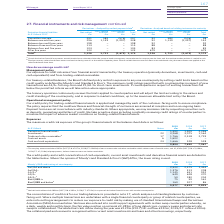According to Bt Group Plc's financial document, What is the cash collateral held by the company in 2019? According to the financial document, £638m. The relevant text states: "a We hold cash collateral of £638m (2017/18: £492m, 2016/17: £702m) in respect of derivative financial assets with certain counterparti..." Also, What is the fair value position in 2019? According to the financial document, £3,289m. The relevant text states: "monthly basis, the fair value position on notional £3,289m of long dated cross-currency swaps and interest rate swaps is collateralised. The related net cash i..." Also, What are the years that Moody’s / S&P credit rating of counterparty is provided? The document contains multiple relevant values: 2017, 2018, 2019. From the document: "At 31 March Notes 2019 £m 2018 £m 2017 £m At 31 March Notes 2019 £m 2018 £m 2017 £m At 31 March Notes 2019 £m 2018 £m 2017 £m..." Also, can you calculate: What is the change in the Aa2/AA and above from 2018 to 2019? Based on the calculation: 2,522 - 2,575, the result is -53 (in millions). This is based on the information: "Aa2/AA and above 2,522 2,575 1,444 Aa3/AA– 1,376 313 208 A1/A+ a 1,145 651 952 A2/A a 649 628 370 A3/A– a 50 180 204 Baa1/ Aa2/AA and above 2,522 2,575 1,444 Aa3/AA– 1,376 313 208 A1/A+ a 1,145 651 95..." The key data points involved are: 2,522, 2,575. Also, can you calculate: What is the average Aa3/AA– for 2017-2019? To answer this question, I need to perform calculations using the financial data. The calculation is: (1,376 + 313 + 208) / 3, which equals 632.33 (in millions). This is based on the information: "Aa2/AA and above 2,522 2,575 1,444 Aa3/AA– 1,376 313 208 A1/A+ a 1,145 651 952 A2/A a 649 628 370 A3/A– a 50 180 204 Baa1/BBB+ a 75 59 561 Baa2/BBB and /AA and above 2,522 2,575 1,444 Aa3/AA– 1,376 31..." The key data points involved are: 1,376, 208, 313. Additionally, In which year(s) is A1/A+a less than 1,000 million? The document shows two values: 2018 and 2017. From the document: "At 31 March Notes 2019 £m 2018 £m 2017 £m At 31 March Notes 2019 £m 2018 £m 2017 £m..." 